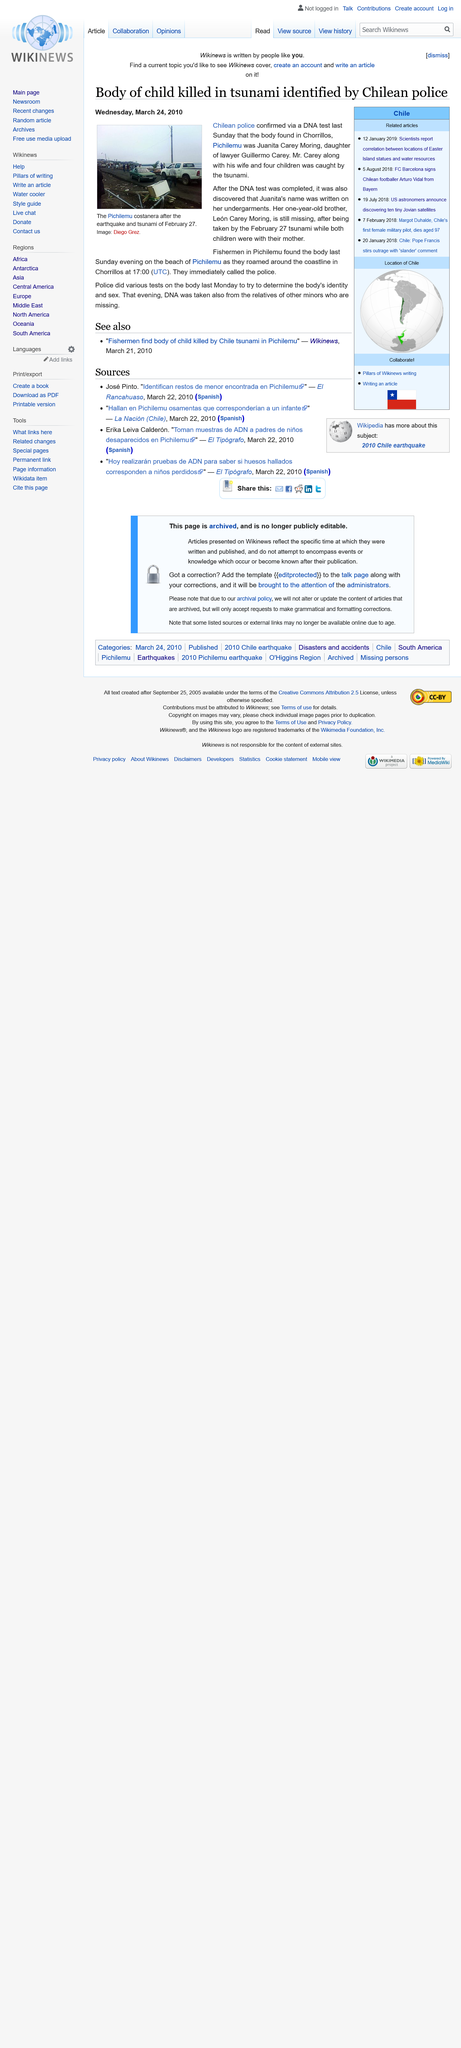List a handful of essential elements in this visual. The body of Juanita Carey Moring was found in Chorrillos, Pichilemu following the February 27th tsunami, and it was discovered to be that of Juanita Carey Moring. On February 27th, the body of an individual was found in the wake of the Chorrillos-Pichilemu tsunami. The identification of the body was made through a DNA test. The body of Juanita Carey Moring was found by fishermen in Pichilemu following the February 27th tsunami in Chorrillos. 